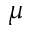<formula> <loc_0><loc_0><loc_500><loc_500>\mu</formula> 